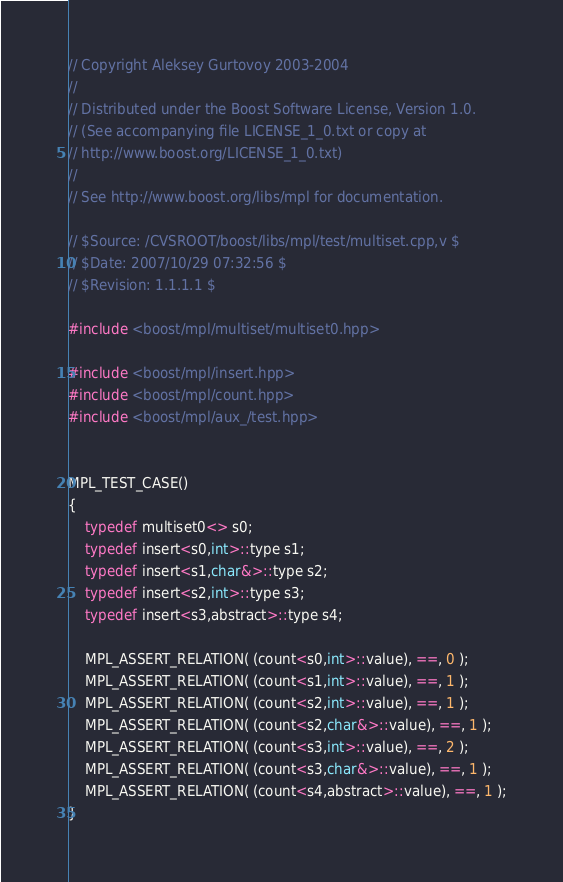<code> <loc_0><loc_0><loc_500><loc_500><_C++_>
// Copyright Aleksey Gurtovoy 2003-2004
//
// Distributed under the Boost Software License, Version 1.0. 
// (See accompanying file LICENSE_1_0.txt or copy at 
// http://www.boost.org/LICENSE_1_0.txt)
//
// See http://www.boost.org/libs/mpl for documentation.

// $Source: /CVSROOT/boost/libs/mpl/test/multiset.cpp,v $
// $Date: 2007/10/29 07:32:56 $
// $Revision: 1.1.1.1 $

#include <boost/mpl/multiset/multiset0.hpp>

#include <boost/mpl/insert.hpp>
#include <boost/mpl/count.hpp>
#include <boost/mpl/aux_/test.hpp>


MPL_TEST_CASE()
{
    typedef multiset0<> s0;
    typedef insert<s0,int>::type s1;
    typedef insert<s1,char&>::type s2;
    typedef insert<s2,int>::type s3;
    typedef insert<s3,abstract>::type s4;
    
    MPL_ASSERT_RELATION( (count<s0,int>::value), ==, 0 );
    MPL_ASSERT_RELATION( (count<s1,int>::value), ==, 1 );
    MPL_ASSERT_RELATION( (count<s2,int>::value), ==, 1 );
    MPL_ASSERT_RELATION( (count<s2,char&>::value), ==, 1 );
    MPL_ASSERT_RELATION( (count<s3,int>::value), ==, 2 );
    MPL_ASSERT_RELATION( (count<s3,char&>::value), ==, 1 );
    MPL_ASSERT_RELATION( (count<s4,abstract>::value), ==, 1 );
}
</code> 